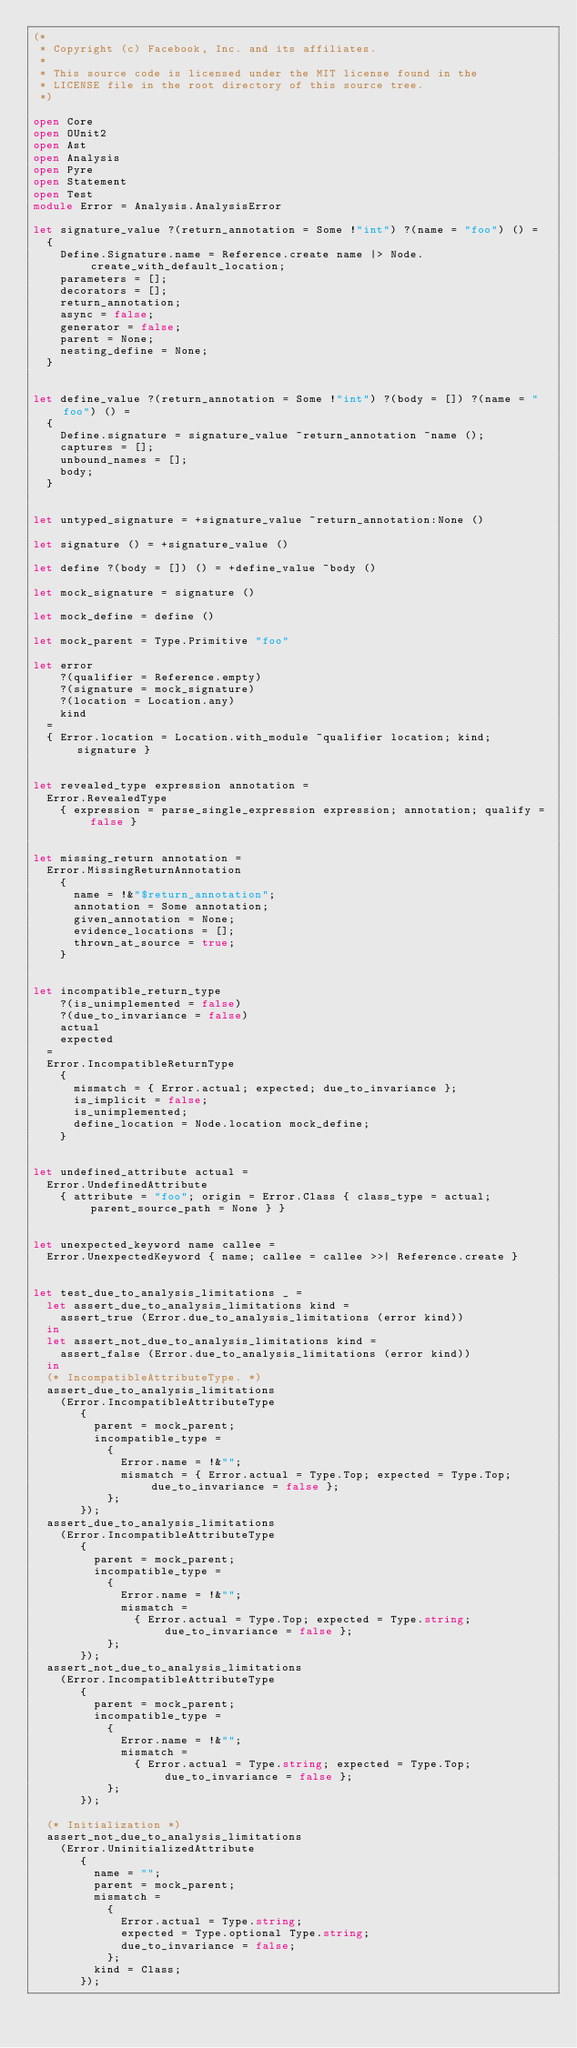Convert code to text. <code><loc_0><loc_0><loc_500><loc_500><_OCaml_>(*
 * Copyright (c) Facebook, Inc. and its affiliates.
 *
 * This source code is licensed under the MIT license found in the
 * LICENSE file in the root directory of this source tree.
 *)

open Core
open OUnit2
open Ast
open Analysis
open Pyre
open Statement
open Test
module Error = Analysis.AnalysisError

let signature_value ?(return_annotation = Some !"int") ?(name = "foo") () =
  {
    Define.Signature.name = Reference.create name |> Node.create_with_default_location;
    parameters = [];
    decorators = [];
    return_annotation;
    async = false;
    generator = false;
    parent = None;
    nesting_define = None;
  }


let define_value ?(return_annotation = Some !"int") ?(body = []) ?(name = "foo") () =
  {
    Define.signature = signature_value ~return_annotation ~name ();
    captures = [];
    unbound_names = [];
    body;
  }


let untyped_signature = +signature_value ~return_annotation:None ()

let signature () = +signature_value ()

let define ?(body = []) () = +define_value ~body ()

let mock_signature = signature ()

let mock_define = define ()

let mock_parent = Type.Primitive "foo"

let error
    ?(qualifier = Reference.empty)
    ?(signature = mock_signature)
    ?(location = Location.any)
    kind
  =
  { Error.location = Location.with_module ~qualifier location; kind; signature }


let revealed_type expression annotation =
  Error.RevealedType
    { expression = parse_single_expression expression; annotation; qualify = false }


let missing_return annotation =
  Error.MissingReturnAnnotation
    {
      name = !&"$return_annotation";
      annotation = Some annotation;
      given_annotation = None;
      evidence_locations = [];
      thrown_at_source = true;
    }


let incompatible_return_type
    ?(is_unimplemented = false)
    ?(due_to_invariance = false)
    actual
    expected
  =
  Error.IncompatibleReturnType
    {
      mismatch = { Error.actual; expected; due_to_invariance };
      is_implicit = false;
      is_unimplemented;
      define_location = Node.location mock_define;
    }


let undefined_attribute actual =
  Error.UndefinedAttribute
    { attribute = "foo"; origin = Error.Class { class_type = actual; parent_source_path = None } }


let unexpected_keyword name callee =
  Error.UnexpectedKeyword { name; callee = callee >>| Reference.create }


let test_due_to_analysis_limitations _ =
  let assert_due_to_analysis_limitations kind =
    assert_true (Error.due_to_analysis_limitations (error kind))
  in
  let assert_not_due_to_analysis_limitations kind =
    assert_false (Error.due_to_analysis_limitations (error kind))
  in
  (* IncompatibleAttributeType. *)
  assert_due_to_analysis_limitations
    (Error.IncompatibleAttributeType
       {
         parent = mock_parent;
         incompatible_type =
           {
             Error.name = !&"";
             mismatch = { Error.actual = Type.Top; expected = Type.Top; due_to_invariance = false };
           };
       });
  assert_due_to_analysis_limitations
    (Error.IncompatibleAttributeType
       {
         parent = mock_parent;
         incompatible_type =
           {
             Error.name = !&"";
             mismatch =
               { Error.actual = Type.Top; expected = Type.string; due_to_invariance = false };
           };
       });
  assert_not_due_to_analysis_limitations
    (Error.IncompatibleAttributeType
       {
         parent = mock_parent;
         incompatible_type =
           {
             Error.name = !&"";
             mismatch =
               { Error.actual = Type.string; expected = Type.Top; due_to_invariance = false };
           };
       });

  (* Initialization *)
  assert_not_due_to_analysis_limitations
    (Error.UninitializedAttribute
       {
         name = "";
         parent = mock_parent;
         mismatch =
           {
             Error.actual = Type.string;
             expected = Type.optional Type.string;
             due_to_invariance = false;
           };
         kind = Class;
       });
</code> 